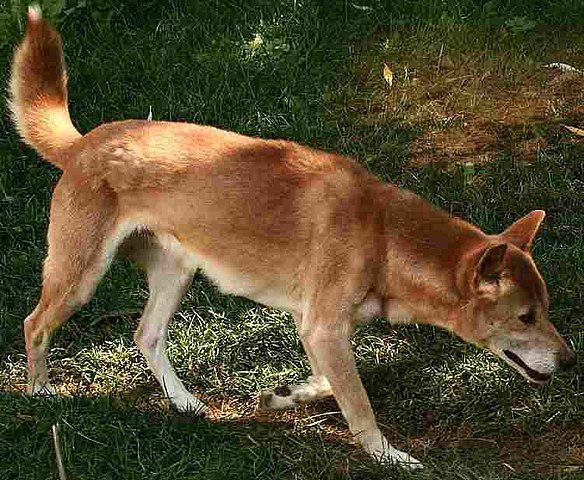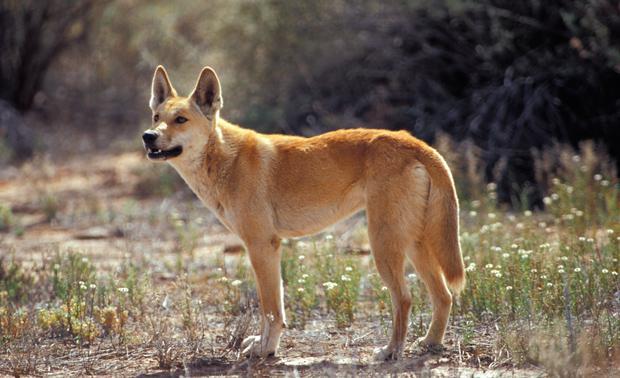The first image is the image on the left, the second image is the image on the right. For the images displayed, is the sentence "One image contains a reclining dingo and the other contains a dingo that is walking with body in profile." factually correct? Answer yes or no. No. The first image is the image on the left, the second image is the image on the right. For the images shown, is this caption "All golden colored dogs are standing up in the grass (not laying down.)" true? Answer yes or no. Yes. 